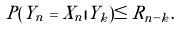<formula> <loc_0><loc_0><loc_500><loc_500>P ( { Y } _ { n } = { X } _ { n } | { Y } _ { k } ) \leq R _ { n - k } .</formula> 